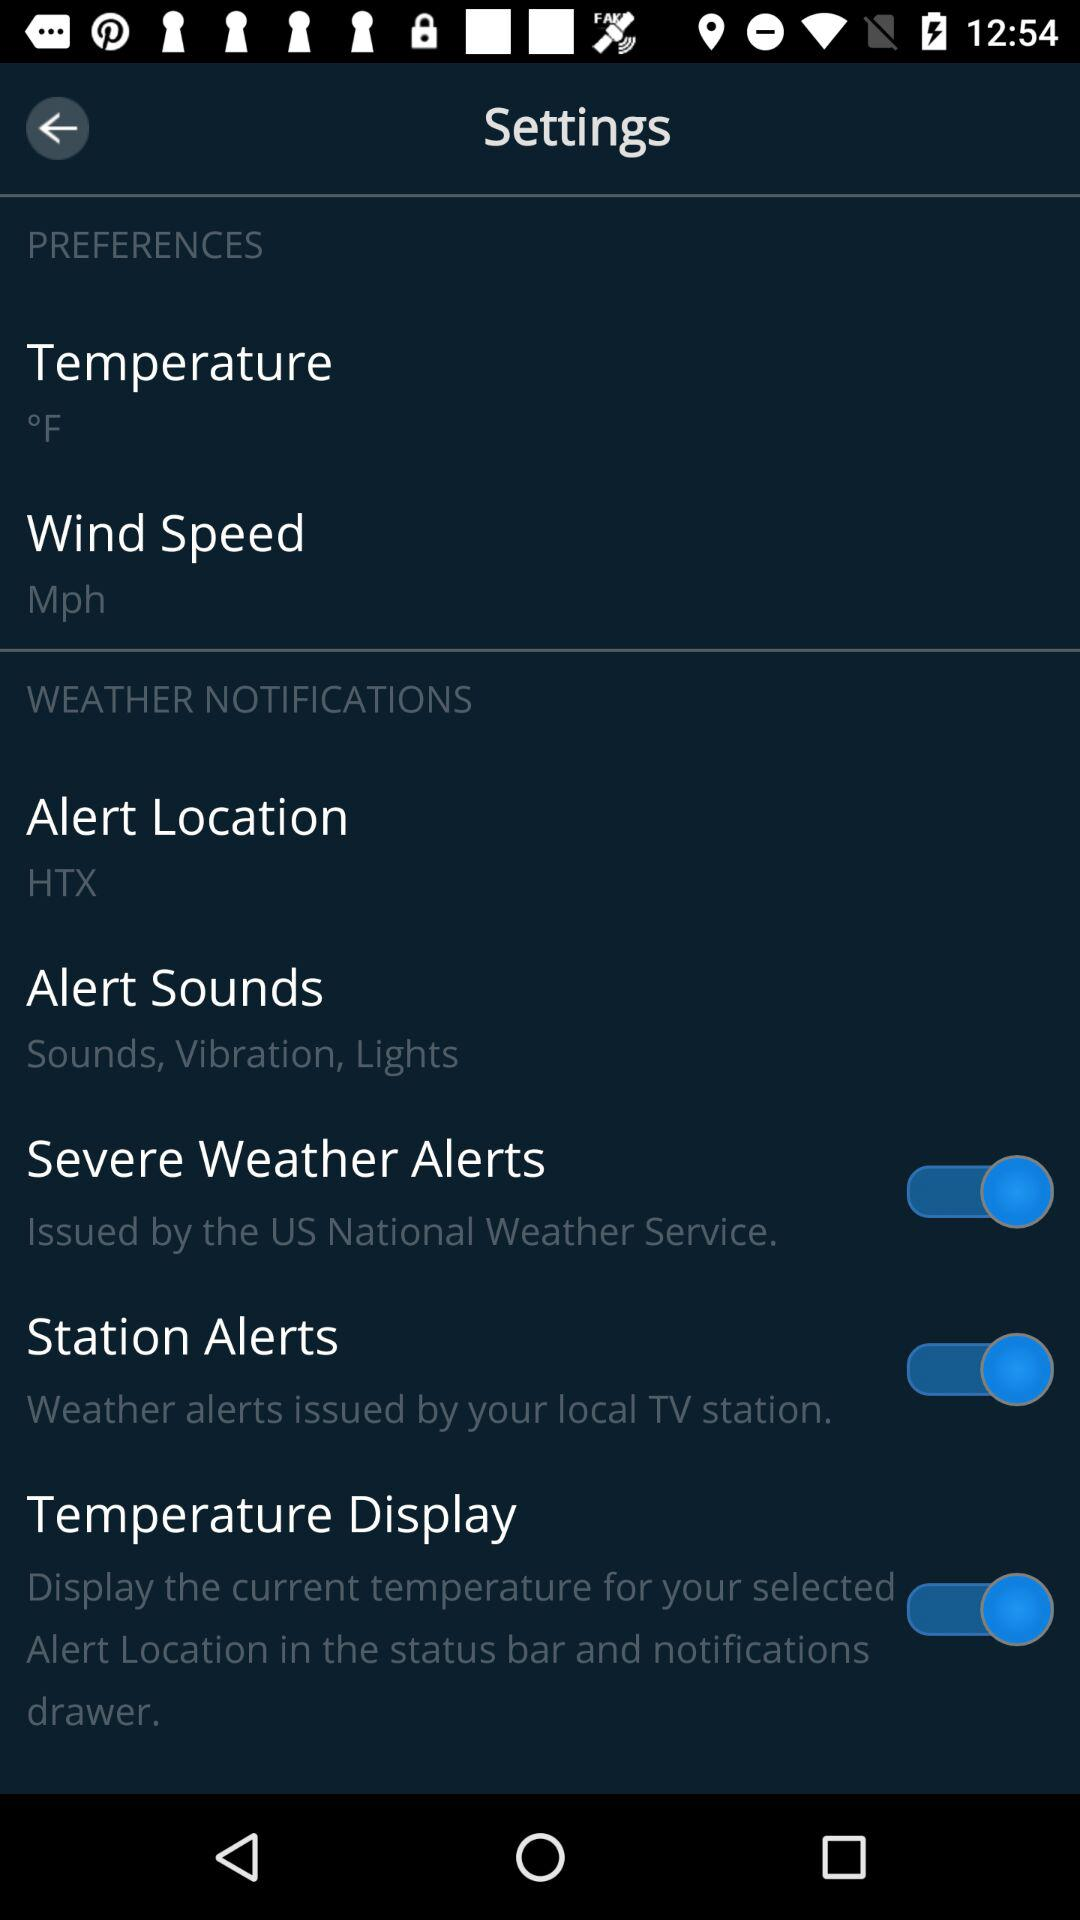How many items are in the 'Weather Notifications' section that have a switch?
Answer the question using a single word or phrase. 3 